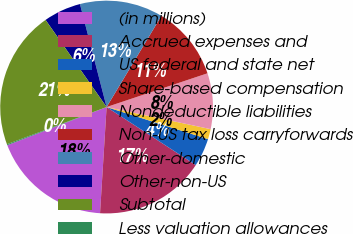Convert chart. <chart><loc_0><loc_0><loc_500><loc_500><pie_chart><fcel>(in millions)<fcel>Accrued expenses and<fcel>US federal and state net<fcel>Share-based compensation<fcel>Nondeductible liabilities<fcel>Non-US tax loss carryforwards<fcel>Other-domestic<fcel>Other-non-US<fcel>Subtotal<fcel>Less valuation allowances<nl><fcel>18.18%<fcel>16.8%<fcel>4.31%<fcel>1.54%<fcel>8.47%<fcel>11.25%<fcel>12.64%<fcel>5.7%<fcel>20.96%<fcel>0.15%<nl></chart> 